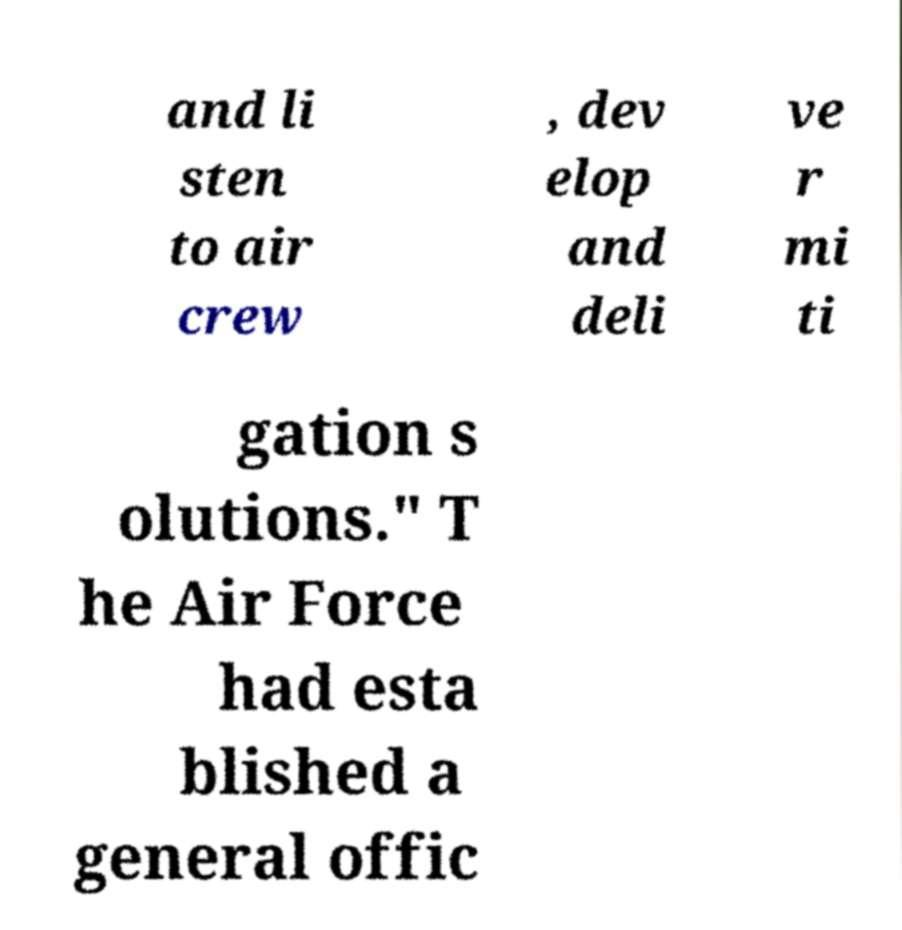What messages or text are displayed in this image? I need them in a readable, typed format. and li sten to air crew , dev elop and deli ve r mi ti gation s olutions." T he Air Force had esta blished a general offic 